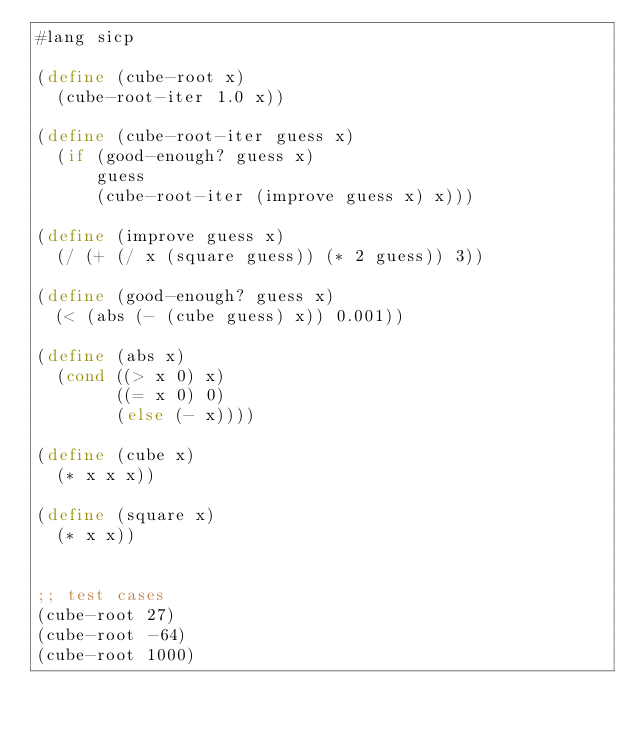Convert code to text. <code><loc_0><loc_0><loc_500><loc_500><_Scheme_>#lang sicp

(define (cube-root x)
  (cube-root-iter 1.0 x))

(define (cube-root-iter guess x)
  (if (good-enough? guess x)
      guess
      (cube-root-iter (improve guess x) x)))

(define (improve guess x)
  (/ (+ (/ x (square guess)) (* 2 guess)) 3))

(define (good-enough? guess x)
  (< (abs (- (cube guess) x)) 0.001))

(define (abs x)
  (cond ((> x 0) x)
        ((= x 0) 0)
        (else (- x))))

(define (cube x)
  (* x x x))

(define (square x)
  (* x x))


;; test cases
(cube-root 27)
(cube-root -64)
(cube-root 1000)
</code> 